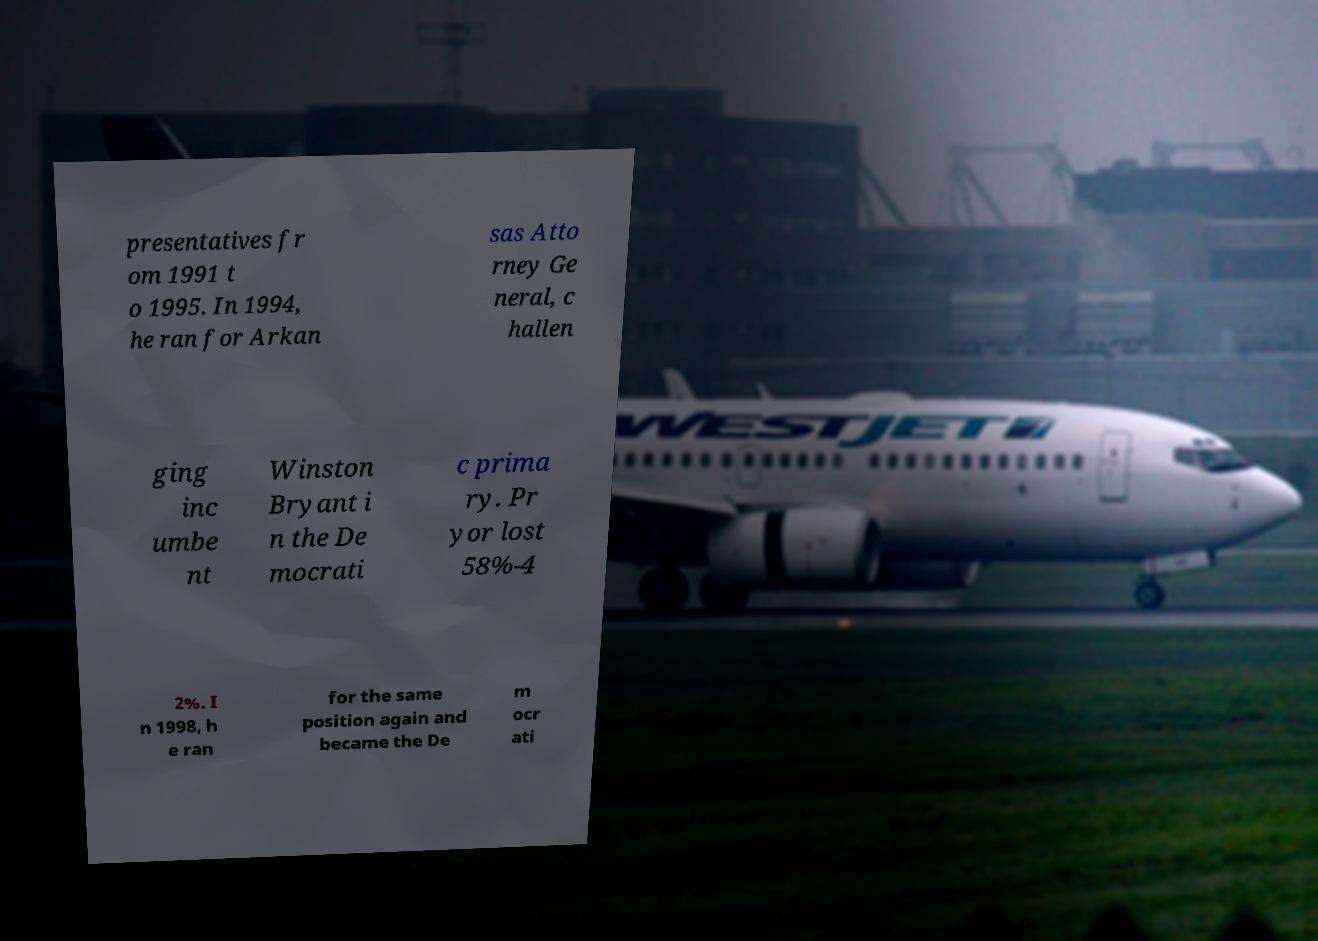Please read and relay the text visible in this image. What does it say? presentatives fr om 1991 t o 1995. In 1994, he ran for Arkan sas Atto rney Ge neral, c hallen ging inc umbe nt Winston Bryant i n the De mocrati c prima ry. Pr yor lost 58%-4 2%. I n 1998, h e ran for the same position again and became the De m ocr ati 